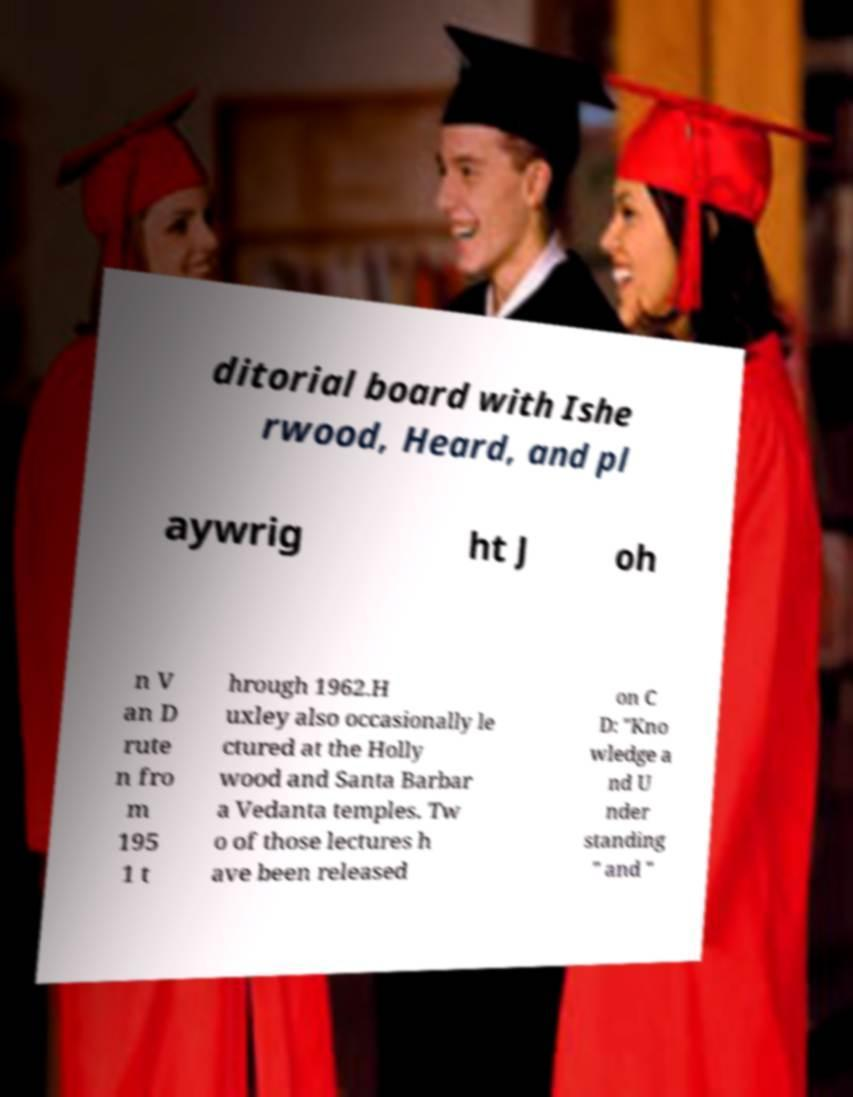There's text embedded in this image that I need extracted. Can you transcribe it verbatim? ditorial board with Ishe rwood, Heard, and pl aywrig ht J oh n V an D rute n fro m 195 1 t hrough 1962.H uxley also occasionally le ctured at the Holly wood and Santa Barbar a Vedanta temples. Tw o of those lectures h ave been released on C D: "Kno wledge a nd U nder standing " and " 